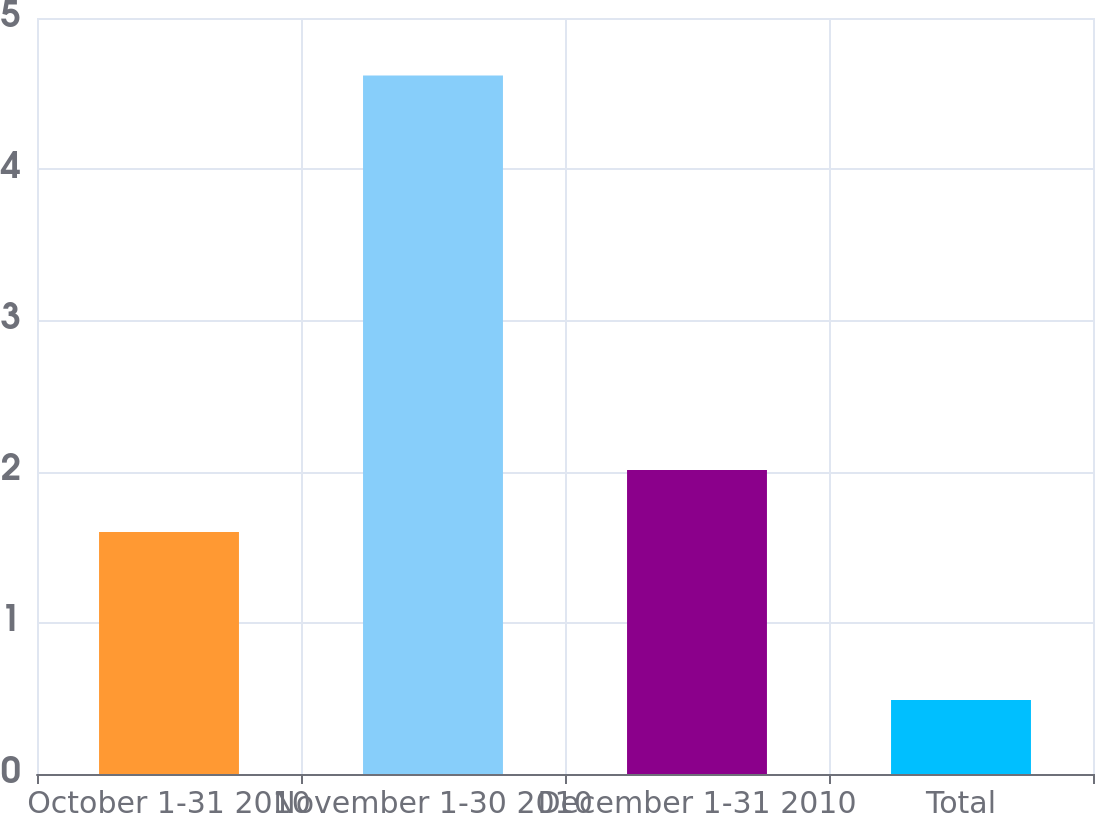Convert chart. <chart><loc_0><loc_0><loc_500><loc_500><bar_chart><fcel>October 1-31 2010<fcel>November 1-30 2010<fcel>December 1-31 2010<fcel>Total<nl><fcel>1.6<fcel>4.62<fcel>2.01<fcel>0.49<nl></chart> 